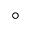<formula> <loc_0><loc_0><loc_500><loc_500>^ { \circ }</formula> 